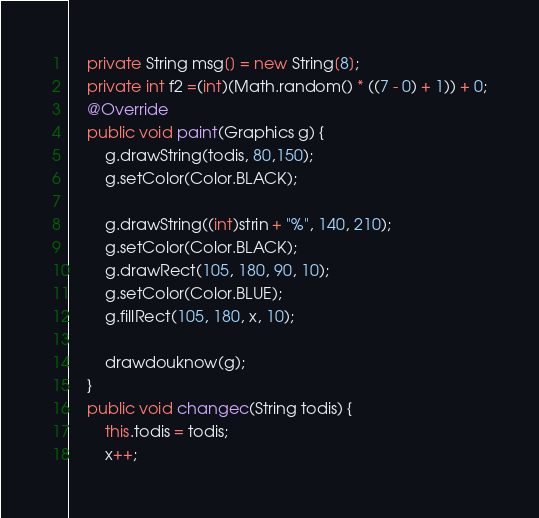<code> <loc_0><loc_0><loc_500><loc_500><_Java_>	private String msg[] = new String[8];
	private int f2 =(int)(Math.random() * ((7 - 0) + 1)) + 0;
	@Override
	public void paint(Graphics g) {
		g.drawString(todis, 80,150);
		g.setColor(Color.BLACK);

		g.drawString((int)strin + "%", 140, 210);
		g.setColor(Color.BLACK);
		g.drawRect(105, 180, 90, 10);
		g.setColor(Color.BLUE);
		g.fillRect(105, 180, x, 10);

		drawdouknow(g);
	}
	public void changec(String todis) {
		this.todis = todis;
		x++; </code> 